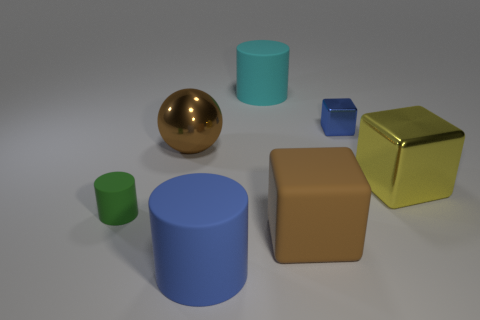There is a big blue object; does it have the same shape as the blue thing that is behind the large brown metallic sphere?
Your response must be concise. No. What number of small objects are both right of the small matte thing and left of the cyan matte object?
Make the answer very short. 0. Is the material of the tiny cube the same as the big thing that is behind the small cube?
Keep it short and to the point. No. Is the number of small rubber objects that are behind the large yellow thing the same as the number of big matte objects?
Your answer should be compact. No. What color is the shiny cube to the right of the tiny cube?
Offer a terse response. Yellow. How many other things are the same color as the small shiny block?
Provide a short and direct response. 1. Is the size of the blue thing on the right side of the cyan thing the same as the small green cylinder?
Offer a terse response. Yes. There is a big brown thing left of the brown matte block; what material is it?
Offer a very short reply. Metal. Is there any other thing that has the same shape as the large brown metal object?
Your answer should be very brief. No. What number of metal things are either big brown things or tiny green things?
Offer a terse response. 1. 